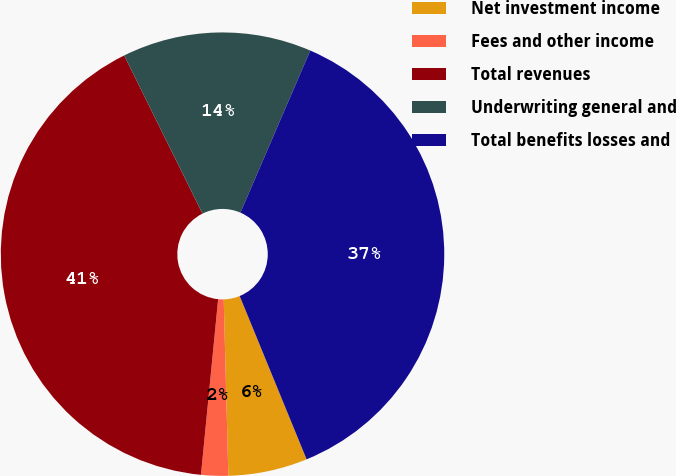<chart> <loc_0><loc_0><loc_500><loc_500><pie_chart><fcel>Net investment income<fcel>Fees and other income<fcel>Total revenues<fcel>Underwriting general and<fcel>Total benefits losses and<nl><fcel>5.77%<fcel>1.97%<fcel>41.13%<fcel>13.79%<fcel>37.33%<nl></chart> 